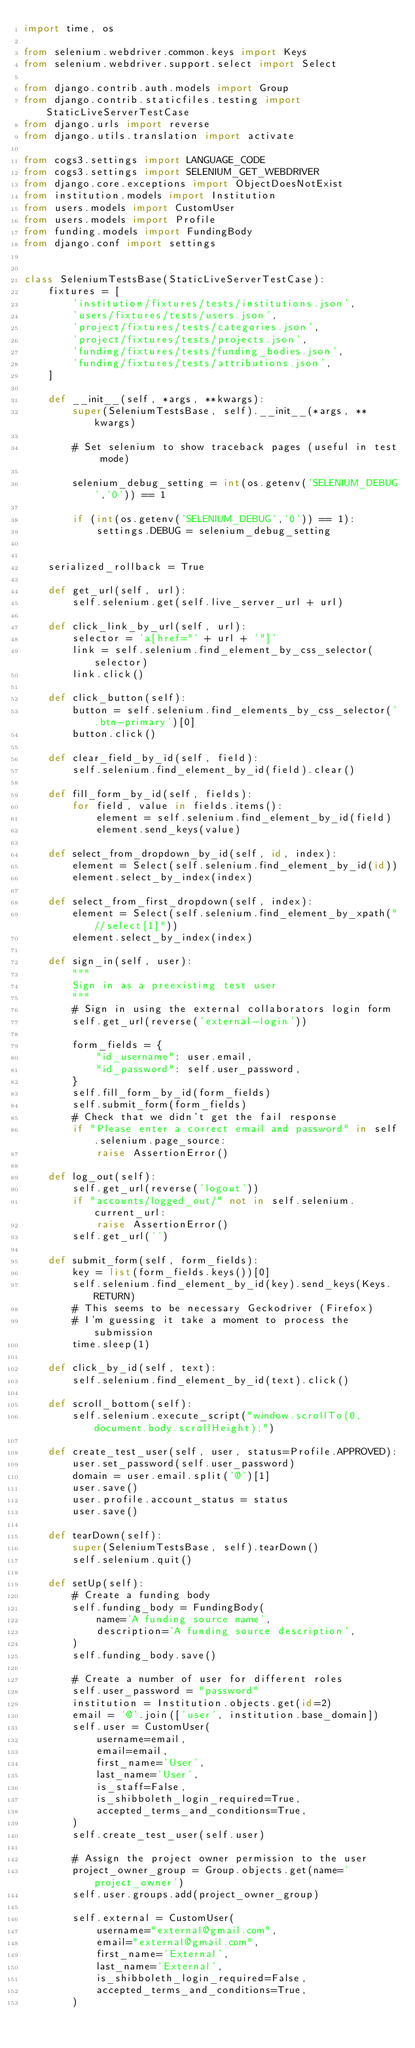Convert code to text. <code><loc_0><loc_0><loc_500><loc_500><_Python_>import time, os

from selenium.webdriver.common.keys import Keys
from selenium.webdriver.support.select import Select

from django.contrib.auth.models import Group
from django.contrib.staticfiles.testing import StaticLiveServerTestCase
from django.urls import reverse
from django.utils.translation import activate

from cogs3.settings import LANGUAGE_CODE
from cogs3.settings import SELENIUM_GET_WEBDRIVER
from django.core.exceptions import ObjectDoesNotExist
from institution.models import Institution
from users.models import CustomUser
from users.models import Profile
from funding.models import FundingBody
from django.conf import settings


class SeleniumTestsBase(StaticLiveServerTestCase):
    fixtures = [
        'institution/fixtures/tests/institutions.json',
        'users/fixtures/tests/users.json',
        'project/fixtures/tests/categories.json',
        'project/fixtures/tests/projects.json',
        'funding/fixtures/tests/funding_bodies.json',
        'funding/fixtures/tests/attributions.json',
    ]

    def __init__(self, *args, **kwargs):
        super(SeleniumTestsBase, self).__init__(*args, **kwargs)

        # Set selenium to show traceback pages (useful in test mode)

        selenium_debug_setting = int(os.getenv('SELENIUM_DEBUG','0')) == 1

        if (int(os.getenv('SELENIUM_DEBUG','0')) == 1):
            settings.DEBUG = selenium_debug_setting


    serialized_rollback = True

    def get_url(self, url):
        self.selenium.get(self.live_server_url + url)

    def click_link_by_url(self, url):
        selector = 'a[href="' + url + '"]'
        link = self.selenium.find_element_by_css_selector(selector)
        link.click()

    def click_button(self):
        button = self.selenium.find_elements_by_css_selector('.btn-primary')[0]
        button.click()

    def clear_field_by_id(self, field):
        self.selenium.find_element_by_id(field).clear()

    def fill_form_by_id(self, fields):
        for field, value in fields.items():
            element = self.selenium.find_element_by_id(field)
            element.send_keys(value)

    def select_from_dropdown_by_id(self, id, index):
        element = Select(self.selenium.find_element_by_id(id))
        element.select_by_index(index)

    def select_from_first_dropdown(self, index):
        element = Select(self.selenium.find_element_by_xpath("//select[1]"))
        element.select_by_index(index)

    def sign_in(self, user):
        """
        Sign in as a preexisting test user
        """
        # Sign in using the external collaborators login form
        self.get_url(reverse('external-login'))

        form_fields = {
            "id_username": user.email,
            "id_password": self.user_password,
        }
        self.fill_form_by_id(form_fields)
        self.submit_form(form_fields)
        # Check that we didn't get the fail response
        if "Please enter a correct email and password" in self.selenium.page_source:
            raise AssertionError()

    def log_out(self):
        self.get_url(reverse('logout'))
        if "accounts/logged_out/" not in self.selenium.current_url:
            raise AssertionError()
        self.get_url('')

    def submit_form(self, form_fields):
        key = list(form_fields.keys())[0]
        self.selenium.find_element_by_id(key).send_keys(Keys.RETURN)
        # This seems to be necessary Geckodriver (Firefox)
        # I'm guessing it take a moment to process the submission
        time.sleep(1)

    def click_by_id(self, text):
        self.selenium.find_element_by_id(text).click()

    def scroll_bottom(self):
        self.selenium.execute_script("window.scrollTo(0, document.body.scrollHeight);")

    def create_test_user(self, user, status=Profile.APPROVED):
        user.set_password(self.user_password)
        domain = user.email.split('@')[1]
        user.save()
        user.profile.account_status = status
        user.save()

    def tearDown(self):
        super(SeleniumTestsBase, self).tearDown()
        self.selenium.quit()

    def setUp(self):
        # Create a funding body
        self.funding_body = FundingBody(
            name='A funding source name',
            description='A funding source description',
        )
        self.funding_body.save()

        # Create a number of user for different roles
        self.user_password = "password"
        institution = Institution.objects.get(id=2)
        email = '@'.join(['user', institution.base_domain])
        self.user = CustomUser(
            username=email,
            email=email,
            first_name='User',
            last_name='User',
            is_staff=False,
            is_shibboleth_login_required=True,
            accepted_terms_and_conditions=True,
        )
        self.create_test_user(self.user)

        # Assign the project owner permission to the user
        project_owner_group = Group.objects.get(name='project_owner')
        self.user.groups.add(project_owner_group)

        self.external = CustomUser(
            username="external@gmail.com",
            email="external@gmail.com",
            first_name='External',
            last_name='External',
            is_shibboleth_login_required=False,
            accepted_terms_and_conditions=True,
        )</code> 